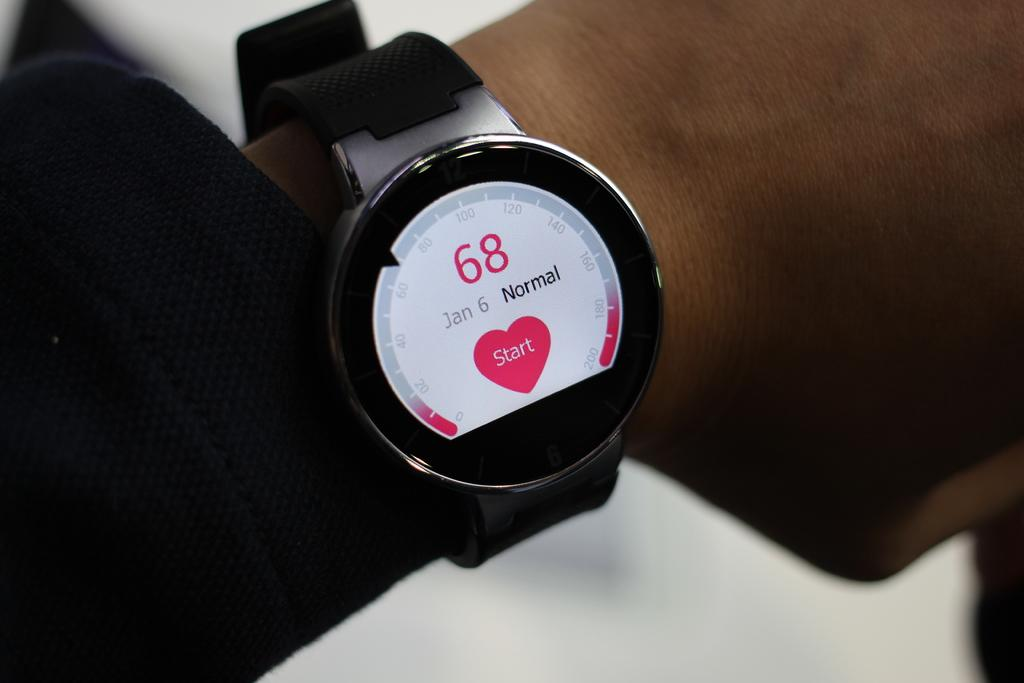<image>
Describe the image concisely. A wrist heart monitor shows the heart beat and start button. 